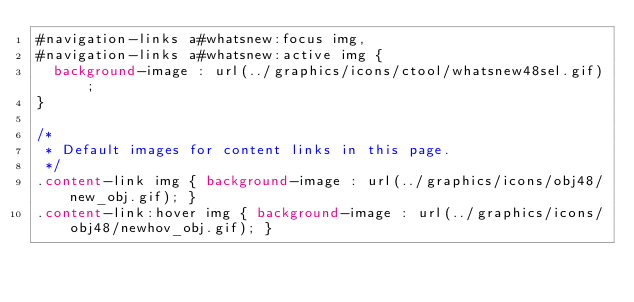<code> <loc_0><loc_0><loc_500><loc_500><_CSS_>#navigation-links a#whatsnew:focus img,
#navigation-links a#whatsnew:active img {
	background-image : url(../graphics/icons/ctool/whatsnew48sel.gif); 
}

/*
 * Default images for content links in this page.
 */
.content-link img { background-image : url(../graphics/icons/obj48/new_obj.gif); }
.content-link:hover img { background-image : url(../graphics/icons/obj48/newhov_obj.gif); }</code> 